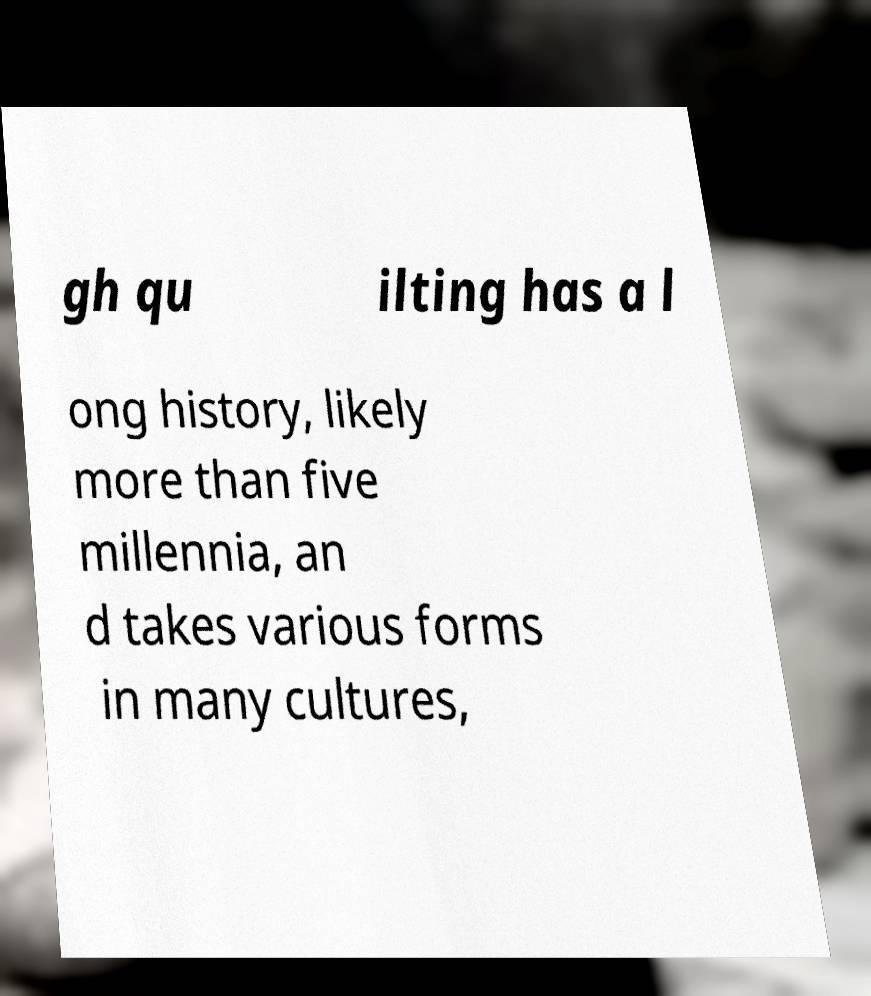Can you accurately transcribe the text from the provided image for me? gh qu ilting has a l ong history, likely more than five millennia, an d takes various forms in many cultures, 